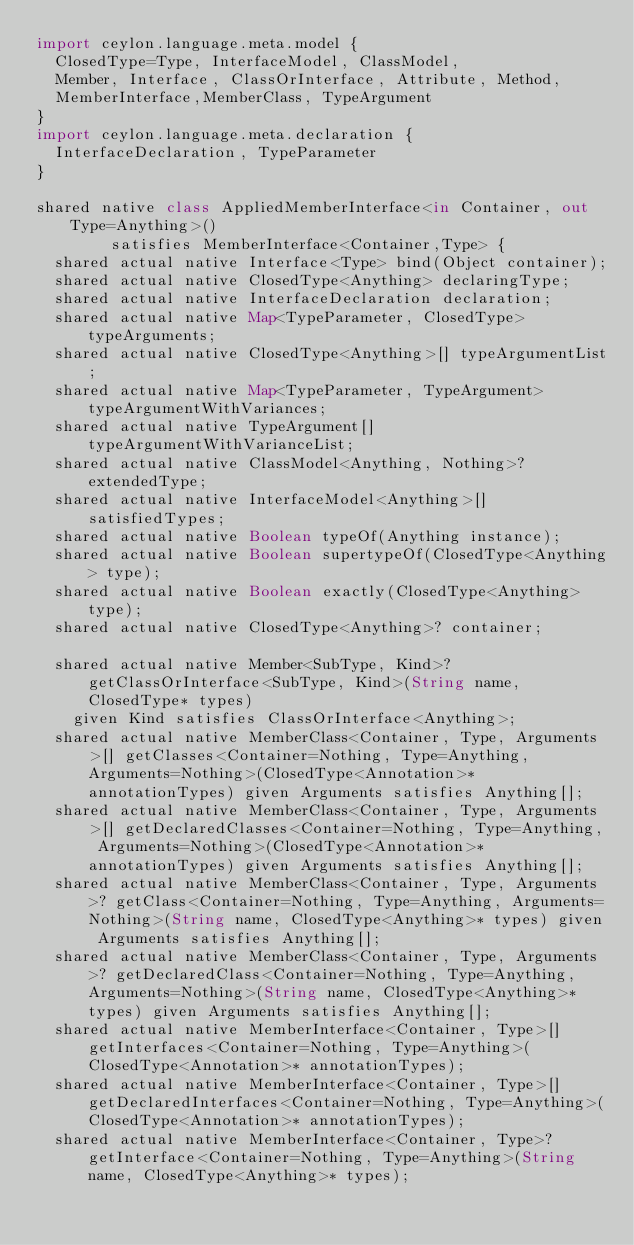<code> <loc_0><loc_0><loc_500><loc_500><_Ceylon_>import ceylon.language.meta.model {
  ClosedType=Type, InterfaceModel, ClassModel,
  Member, Interface, ClassOrInterface, Attribute, Method,
  MemberInterface,MemberClass, TypeArgument
}
import ceylon.language.meta.declaration {
  InterfaceDeclaration, TypeParameter
}

shared native class AppliedMemberInterface<in Container, out Type=Anything>()
        satisfies MemberInterface<Container,Type> {
  shared actual native Interface<Type> bind(Object container);
  shared actual native ClosedType<Anything> declaringType;
  shared actual native InterfaceDeclaration declaration;
  shared actual native Map<TypeParameter, ClosedType> typeArguments;
  shared actual native ClosedType<Anything>[] typeArgumentList;
  shared actual native Map<TypeParameter, TypeArgument> typeArgumentWithVariances;
  shared actual native TypeArgument[] typeArgumentWithVarianceList;
  shared actual native ClassModel<Anything, Nothing>? extendedType;
  shared actual native InterfaceModel<Anything>[] satisfiedTypes;
  shared actual native Boolean typeOf(Anything instance);
  shared actual native Boolean supertypeOf(ClosedType<Anything> type);
  shared actual native Boolean exactly(ClosedType<Anything> type);
  shared actual native ClosedType<Anything>? container;

  shared actual native Member<SubType, Kind>? getClassOrInterface<SubType, Kind>(String name, ClosedType* types)
    given Kind satisfies ClassOrInterface<Anything>;
  shared actual native MemberClass<Container, Type, Arguments>[] getClasses<Container=Nothing, Type=Anything, Arguments=Nothing>(ClosedType<Annotation>* annotationTypes) given Arguments satisfies Anything[];
  shared actual native MemberClass<Container, Type, Arguments>[] getDeclaredClasses<Container=Nothing, Type=Anything, Arguments=Nothing>(ClosedType<Annotation>* annotationTypes) given Arguments satisfies Anything[];
  shared actual native MemberClass<Container, Type, Arguments>? getClass<Container=Nothing, Type=Anything, Arguments=Nothing>(String name, ClosedType<Anything>* types) given Arguments satisfies Anything[];
  shared actual native MemberClass<Container, Type, Arguments>? getDeclaredClass<Container=Nothing, Type=Anything, Arguments=Nothing>(String name, ClosedType<Anything>* types) given Arguments satisfies Anything[];
  shared actual native MemberInterface<Container, Type>[] getInterfaces<Container=Nothing, Type=Anything>(ClosedType<Annotation>* annotationTypes);
  shared actual native MemberInterface<Container, Type>[] getDeclaredInterfaces<Container=Nothing, Type=Anything>(ClosedType<Annotation>* annotationTypes);
  shared actual native MemberInterface<Container, Type>? getInterface<Container=Nothing, Type=Anything>(String name, ClosedType<Anything>* types);</code> 